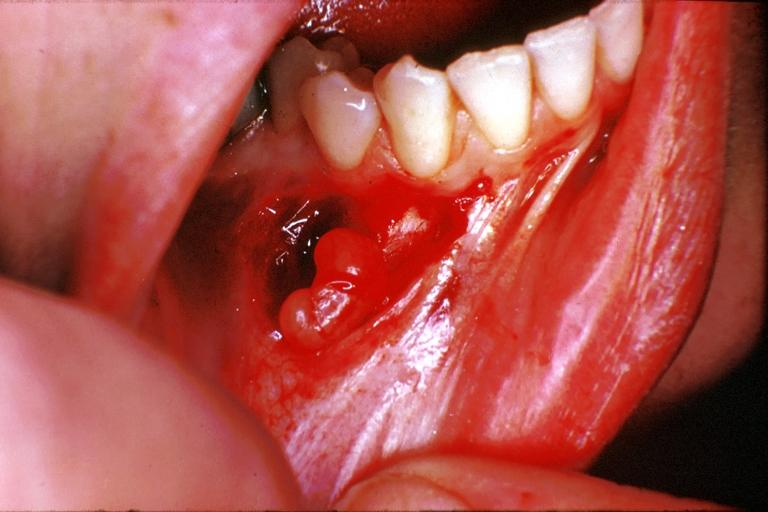where is this?
Answer the question using a single word or phrase. Oral 